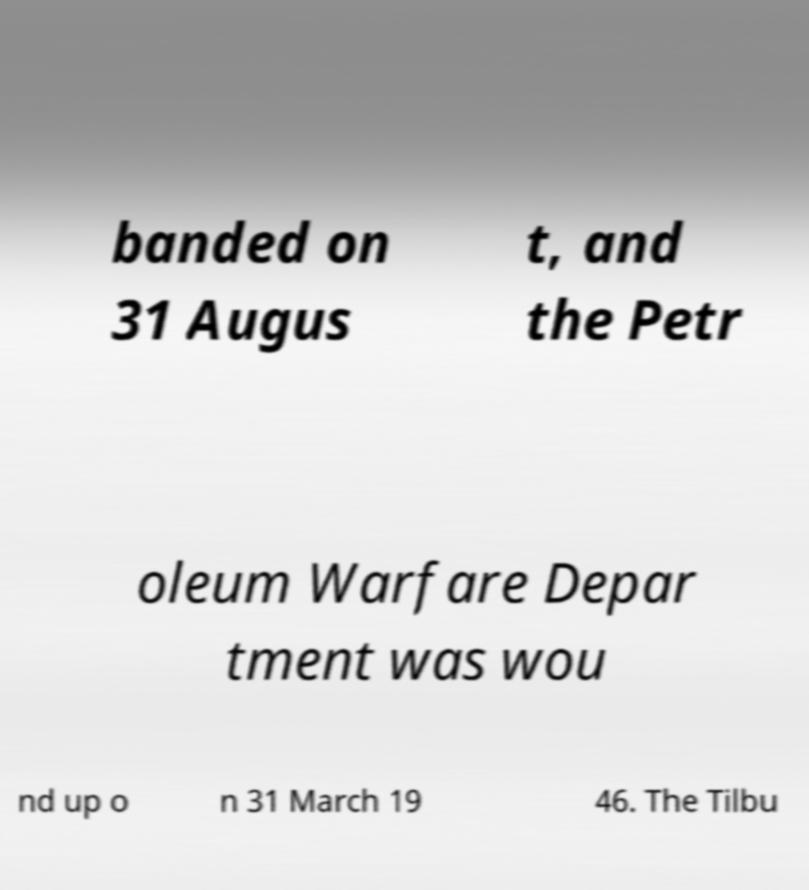Can you read and provide the text displayed in the image?This photo seems to have some interesting text. Can you extract and type it out for me? banded on 31 Augus t, and the Petr oleum Warfare Depar tment was wou nd up o n 31 March 19 46. The Tilbu 